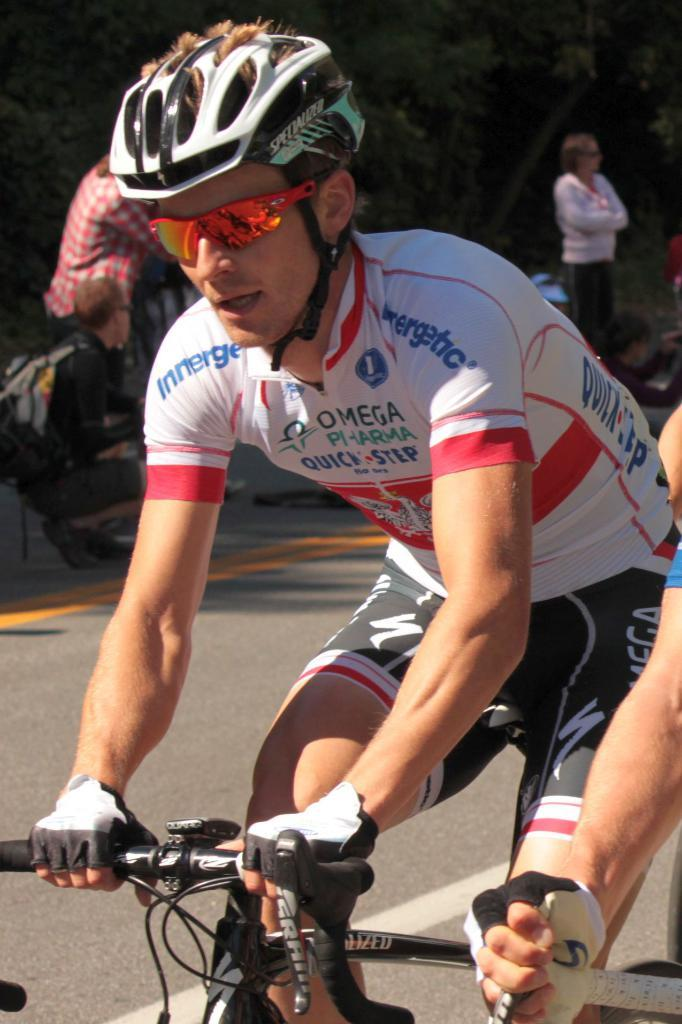What are the people in the image doing? There are people standing and a person riding a bicycle in the image. Where are the people and the bicycle located? They are on a road in the image. What else can be seen in the image? There is a person sitting in the image. What is visible in the background of the image? Trees are visible in the background of the image. What is the teaching rate of the minister in the image? There is no minister or teaching rate mentioned in the image; it features people and a bicycle on a road. 